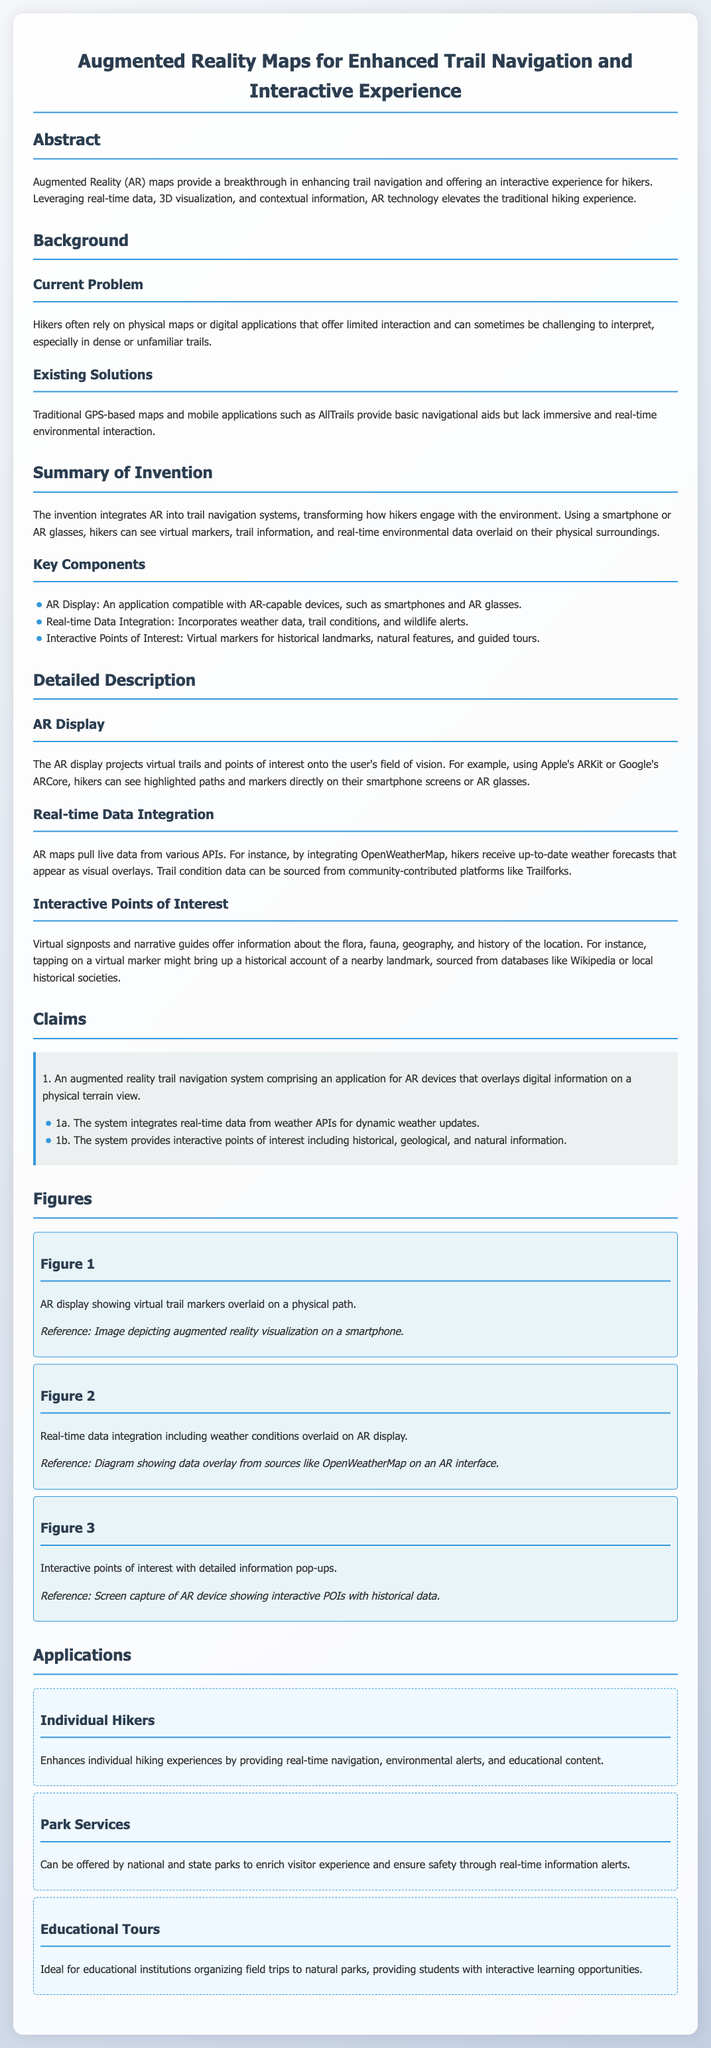What is the title of the document? The title is found at the top of the document, indicating the focus of the patent application.
Answer: Augmented Reality Maps for Enhanced Trail Navigation and Interactive Experience What are the key components of the invention? The key components are listed under "Summary of Invention," providing essential technologies utilized in the system.
Answer: AR Display, Real-time Data Integration, Interactive Points of Interest What is a current problem mentioned? The document describes issues faced by hikers currently in the "Current Problem" section.
Answer: Physical maps or digital applications offering limited interaction How does the AR display work? The functioning of the AR display is detailed in the "Detailed Description" section, explaining its operation.
Answer: Projects virtual trails and points of interest How many claims are made in the patent application? The number of claims can be determined by counting the claim sections under the "Claims" part of the document.
Answer: 1 What is an application for the technology mentioned? The document lists various applications indicating how the technology can be utilized.
Answer: Individual Hikers What type of data is integrated in real-time? The document outlines specific types of data that the system receives dynamically under the "Real-time Data Integration" section.
Answer: Weather data, trail conditions, wildlife alerts What platforms might the AR maps source trail conditions from? The source for trail condition data is mentioned in the "Real-time Data Integration" part of the document.
Answer: Community-contributed platforms like Trailforks What visual feature does Figure 2 illustrate? The caption in Figure 2 describes the visual aspect being represented, which relates to the system's functionality.
Answer: Real-time data integration including weather conditions 